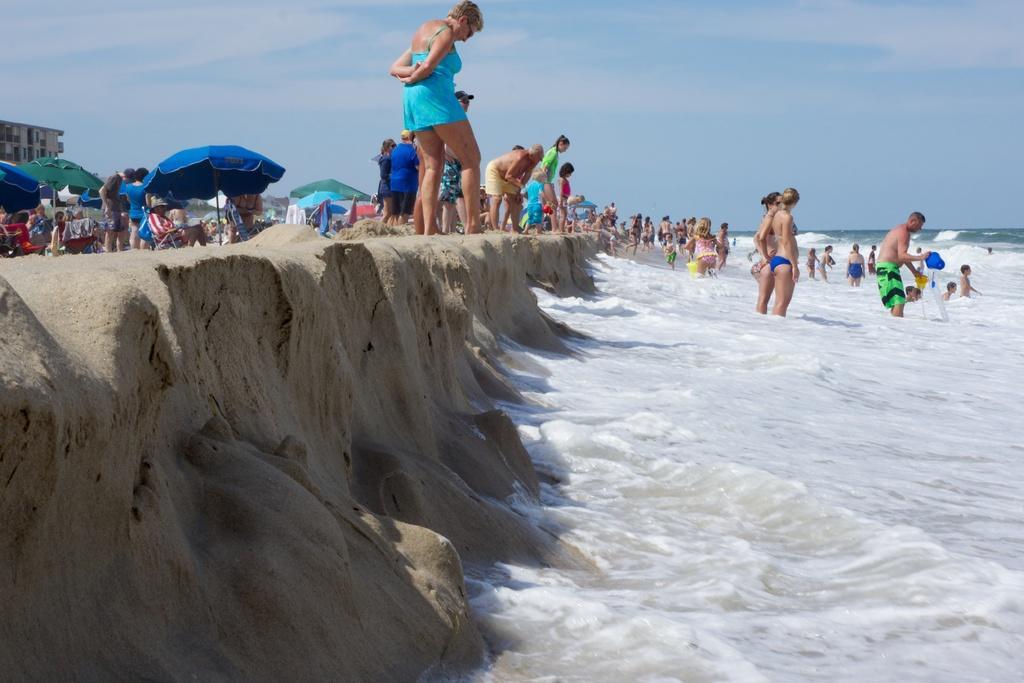Could you give a brief overview of what you see in this image? This picture shows few people standing in the water and few are standing on the seashore and we see tents and a building and we see a blue cloudy sky. 